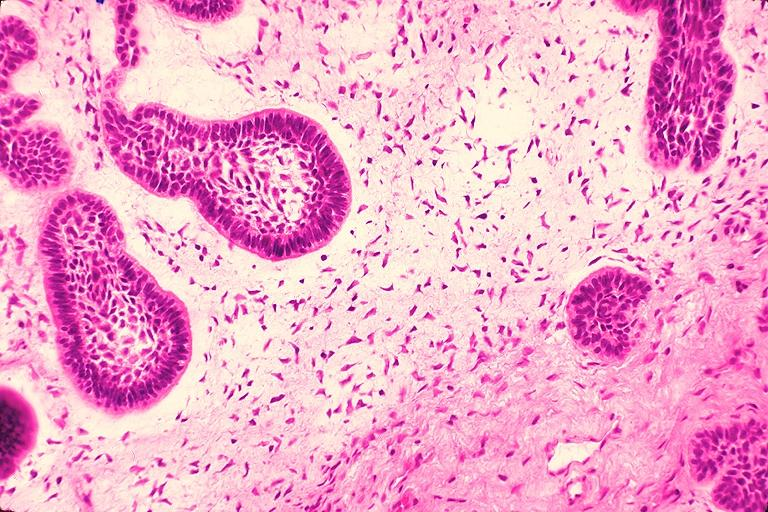where is this?
Answer the question using a single word or phrase. Oral 